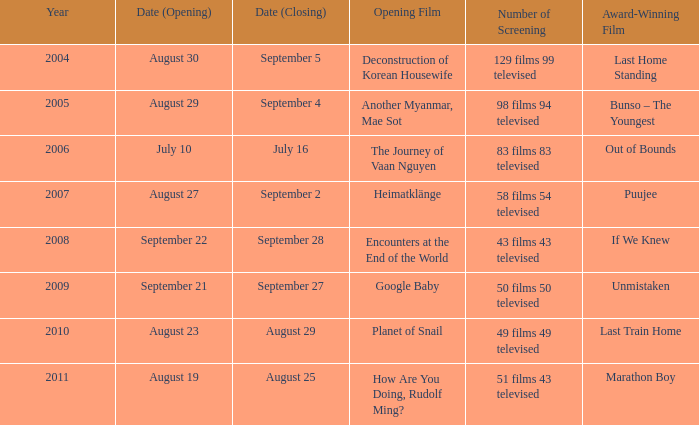What is the number of acclaimed films that include the opening of encounters at the end of the world? 1.0. 